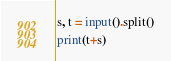Convert code to text. <code><loc_0><loc_0><loc_500><loc_500><_Python_>s, t = input().split()

print(t+s)</code> 